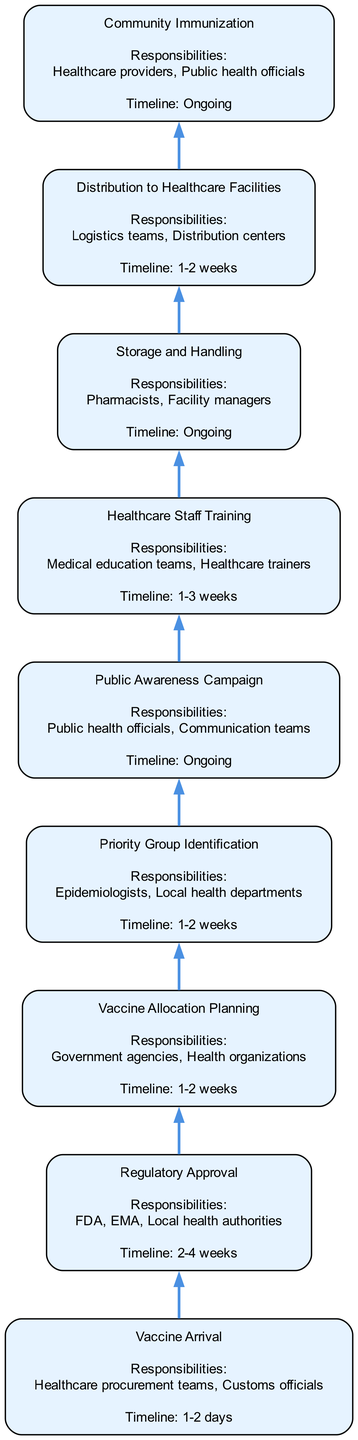What is the final step in the vaccination rollout strategy? The final step in the diagram is "Community Immunization," which involves achieving herd immunity through widespread vaccination. This is the topmost node, indicating the culmination of the prior steps.
Answer: Community Immunization What is the timeline for "Vaccine Arrival"? According to the diagram, the timeline for "Vaccine Arrival" is specified as "1-2 days." This reflects the prompt receipt of vaccine shipments from manufacturers after regulatory approvals.
Answer: 1-2 days Who is responsible for "Priority Group Identification"? The responsibilities of "Priority Group Identification" fall under "Epidemiologists" and "Local health departments," as stated in the diagram. They are key players in identifying high-risk populations for vaccination.
Answer: Epidemiologists, Local health departments What follows after "Regulatory Approval"? The step that follows "Regulatory Approval" is "Vaccine Allocation Planning," indicating that once the vaccines receive the necessary approvals, planning for their distribution begins.
Answer: Vaccine Allocation Planning How many nodes are there in the diagram? The diagram contains a total of 9 nodes, each representing a key step in the vaccination rollout strategy, starting from "Vaccine Arrival" to "Community Immunization."
Answer: 9 What is the responsibility outlined for "Storage and Handling"? The responsibilities for "Storage and Handling" are assigned to "Pharmacists" and "Facility managers," who ensure that the vaccines are kept at proper storage conditions.
Answer: Pharmacists, Facility managers Describe the nature of the "Public Awareness Campaign." The "Public Awareness Campaign" is described as an ongoing effort that involves informing the public about vaccine benefits, safety, and efficacy, reflecting its importance throughout the vaccination process.
Answer: Ongoing What is the timeline for "Healthcare Staff Training"? "Healthcare Staff Training" is indicated to take "1-3 weeks," which allows enough time for staff to be adequately trained on vaccination protocols before starting the immunization efforts.
Answer: 1-3 weeks Which node describes the logistics involved in vaccine distribution? The node that details the logistics for vaccine distribution is "Distribution to Healthcare Facilities," which specifically focuses on delivering vaccines to local hospitals and clinics.
Answer: Distribution to Healthcare Facilities 